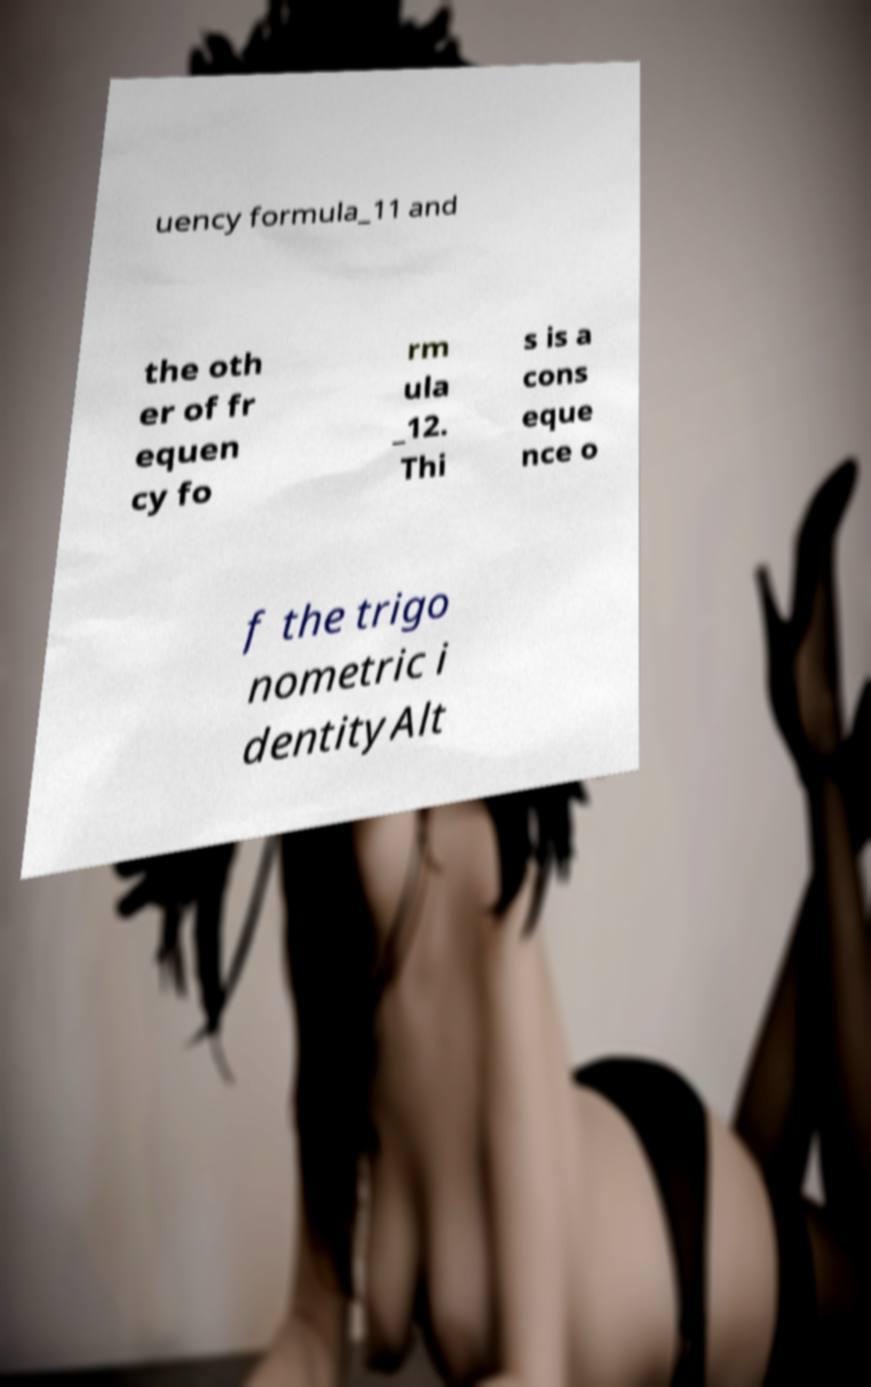I need the written content from this picture converted into text. Can you do that? uency formula_11 and the oth er of fr equen cy fo rm ula _12. Thi s is a cons eque nce o f the trigo nometric i dentityAlt 